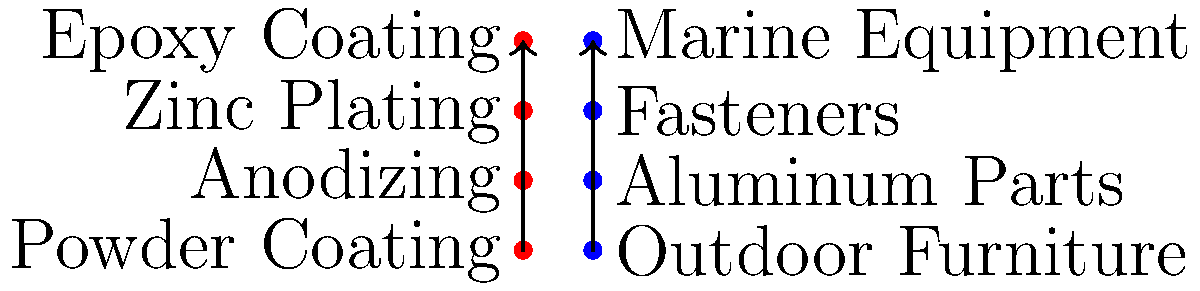Match each protective coating to its most appropriate hardware application:

1. Powder Coating
2. Anodizing
3. Zinc Plating
4. Epoxy Coating

A. Aluminum Parts
B. Fasteners
C. Marine Equipment
D. Outdoor Furniture To match the protective coatings to their most appropriate hardware applications, let's consider each coating's properties and typical uses:

1. Powder Coating:
   - Durable, weather-resistant finish
   - Excellent for outdoor use
   - Ideal for: D. Outdoor Furniture

2. Anodizing:
   - Electrochemical process that creates a hard, corrosion-resistant surface
   - Primarily used on aluminum
   - Ideal for: A. Aluminum Parts

3. Zinc Plating:
   - Provides corrosion resistance
   - Commonly used on small metal parts
   - Ideal for: B. Fasteners

4. Epoxy Coating:
   - Highly resistant to chemicals and corrosion
   - Excellent for harsh environments
   - Ideal for: C. Marine Equipment

By understanding the properties and typical applications of each coating, we can match them to the most suitable hardware applications.
Answer: 1-D, 2-A, 3-B, 4-C 